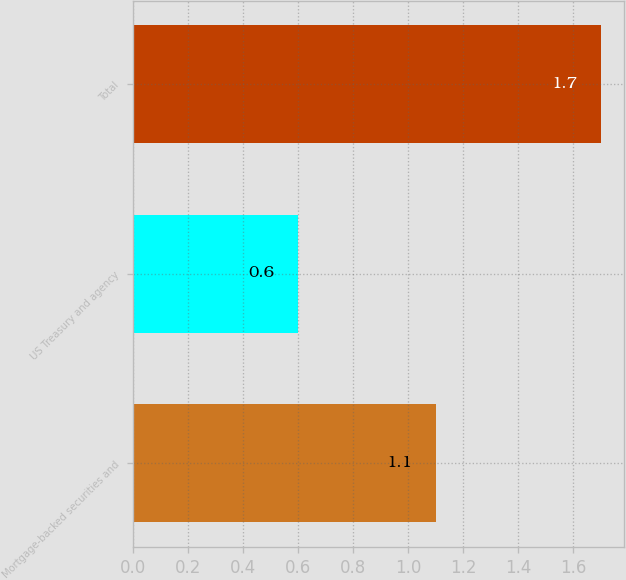Convert chart. <chart><loc_0><loc_0><loc_500><loc_500><bar_chart><fcel>Mortgage-backed securities and<fcel>US Treasury and agency<fcel>Total<nl><fcel>1.1<fcel>0.6<fcel>1.7<nl></chart> 